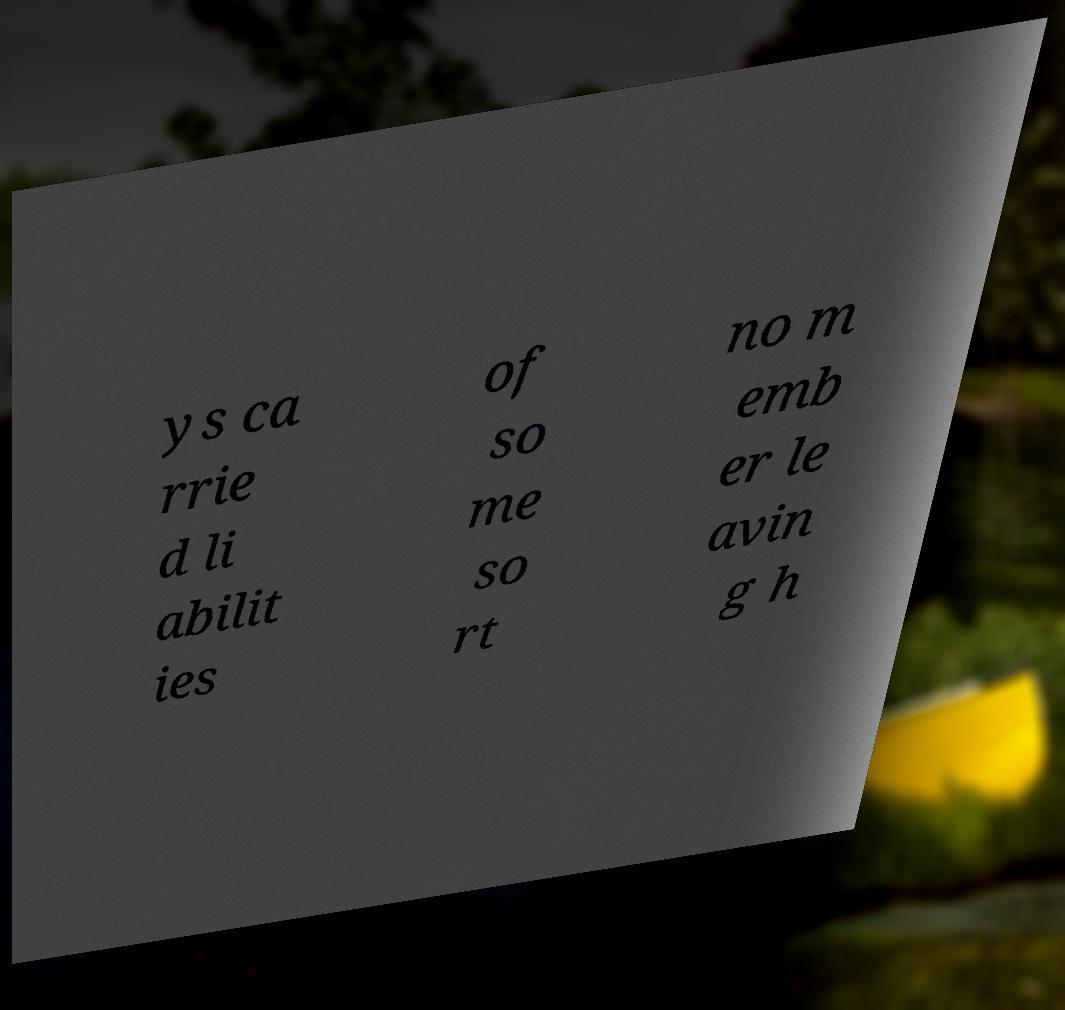What messages or text are displayed in this image? I need them in a readable, typed format. ys ca rrie d li abilit ies of so me so rt no m emb er le avin g h 